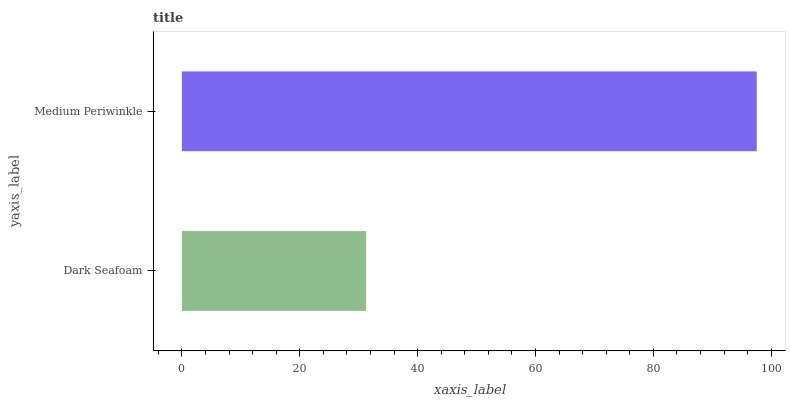Is Dark Seafoam the minimum?
Answer yes or no. Yes. Is Medium Periwinkle the maximum?
Answer yes or no. Yes. Is Medium Periwinkle the minimum?
Answer yes or no. No. Is Medium Periwinkle greater than Dark Seafoam?
Answer yes or no. Yes. Is Dark Seafoam less than Medium Periwinkle?
Answer yes or no. Yes. Is Dark Seafoam greater than Medium Periwinkle?
Answer yes or no. No. Is Medium Periwinkle less than Dark Seafoam?
Answer yes or no. No. Is Medium Periwinkle the high median?
Answer yes or no. Yes. Is Dark Seafoam the low median?
Answer yes or no. Yes. Is Dark Seafoam the high median?
Answer yes or no. No. Is Medium Periwinkle the low median?
Answer yes or no. No. 